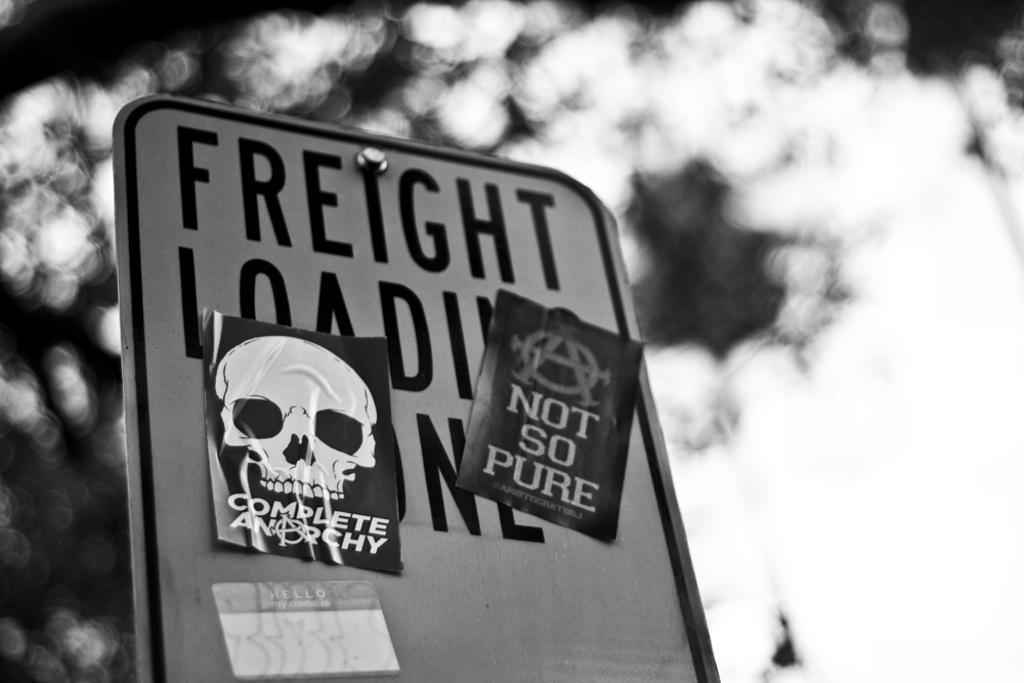Please provide a concise description of this image. In this image I can see a board, on the board I can see few papers attached to it and the image is in black and white. 